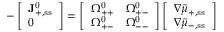<formula> <loc_0><loc_0><loc_500><loc_500>- \left [ \begin{array} { l } { J _ { + , { s s } } ^ { 0 } } \\ { 0 } \end{array} \right ] = \left [ \begin{array} { l l } { \Omega _ { + + } ^ { 0 } } & { \Omega _ { + - } ^ { 0 } } \\ { \Omega _ { + - } ^ { 0 } } & { \Omega _ { - - } ^ { 0 } } \end{array} \right ] \left [ \begin{array} { l } { \nabla \tilde { \mu } _ { + , { s s } } } \\ { \nabla \tilde { \mu } _ { - , { s s } } } \end{array} \right ]</formula> 